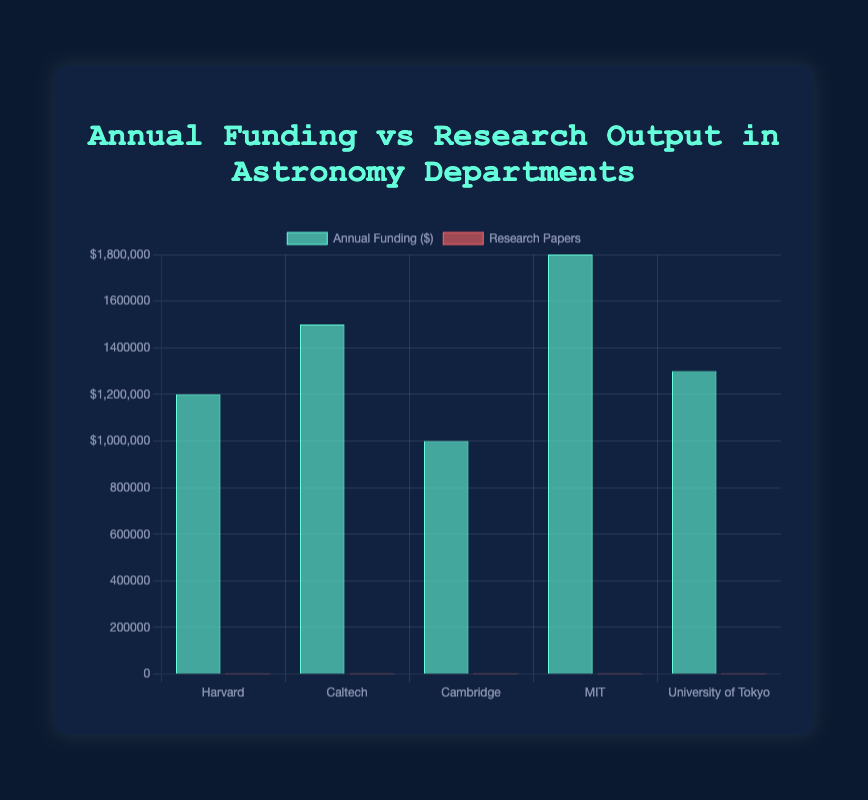what is the total funding allocated to Harvard and MIT? Sum the funding for Harvard (1200000) and MIT (1800000). 1200000 + 1800000 = 3000000
Answer: 3000000 Which department published the most research papers? Look at the data for the highest value under 'Research Papers'. MIT has 180 research papers, which is the highest.
Answer: MIT What is the difference between the annual funding of Caltech and Cambridge? Subtract Cambridge's funding (1000000) from Caltech's funding (1500000). 1500000 - 1000000 = 500000
Answer: 500000 Which department has the least funding? Look at the data and find the smallest value under 'Annual Funding'. Cambridge has the least funding at 1000000.
Answer: Cambridge Which institution has a higher research output: University of Tokyo or Harvard? Compare the research papers published by University of Tokyo (110) and Harvard (120). Harvard has a higher research output.
Answer: Harvard How much more funding does MIT receive compared to the University of Tokyo? Subtract the University of Tokyo's funding (1300000) from MIT's funding (1800000). 1800000 - 1300000 = 500000
Answer: 500000 What color represents the research papers in the chart? The bars representing research papers are colored red.
Answer: red Calculate the average number of research papers published by all departments. Sum the research papers (120, 150, 90, 180, 110) which equals 650. Divide by the number of departments (5). 650 / 5 = 130
Answer: 130 Which department has the lower research output, Cambridge or University of Tokyo? Compare the research papers published by Cambridge (90) and University of Tokyo (110). Cambridge has the lower research output.
Answer: Cambridge What is the total amount of funding received by all departments combined? Sum the funding for Harvard (1200000), Caltech (1500000), Cambridge (1000000), MIT (1800000), and University of Tokyo (1300000). The total is 1200000 + 1500000 + 1000000 + 1800000 + 1300000 = 6800000
Answer: 6800000 